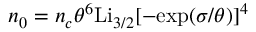<formula> <loc_0><loc_0><loc_500><loc_500>n _ { 0 } = { n _ { c } } { \theta ^ { 6 } } { L } { { i } _ { 3 / 2 } } [ - { e x p ( } \sigma { / } \theta { ) } ] ^ { 4 }</formula> 